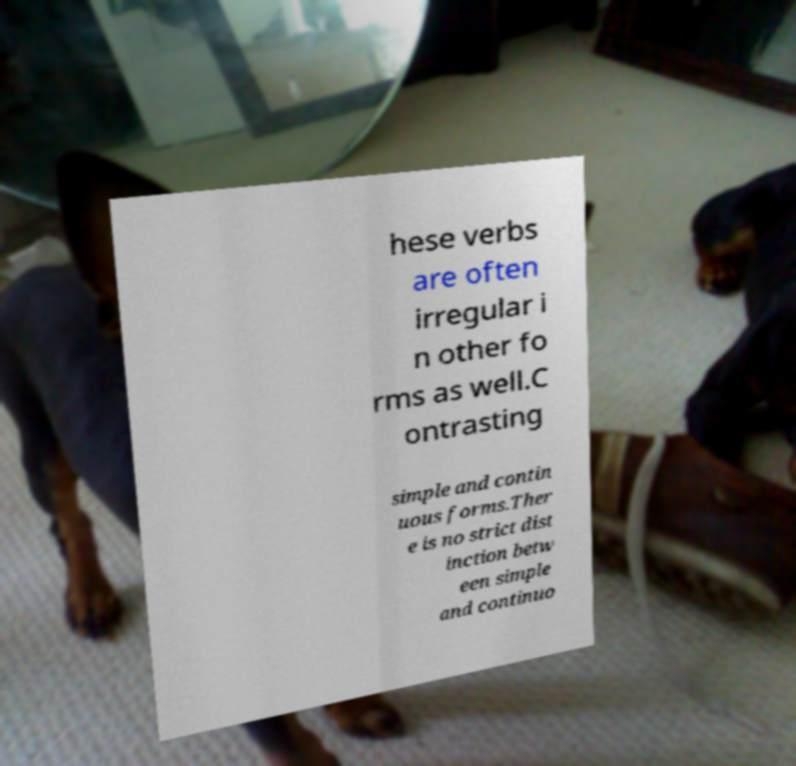What messages or text are displayed in this image? I need them in a readable, typed format. hese verbs are often irregular i n other fo rms as well.C ontrasting simple and contin uous forms.Ther e is no strict dist inction betw een simple and continuo 